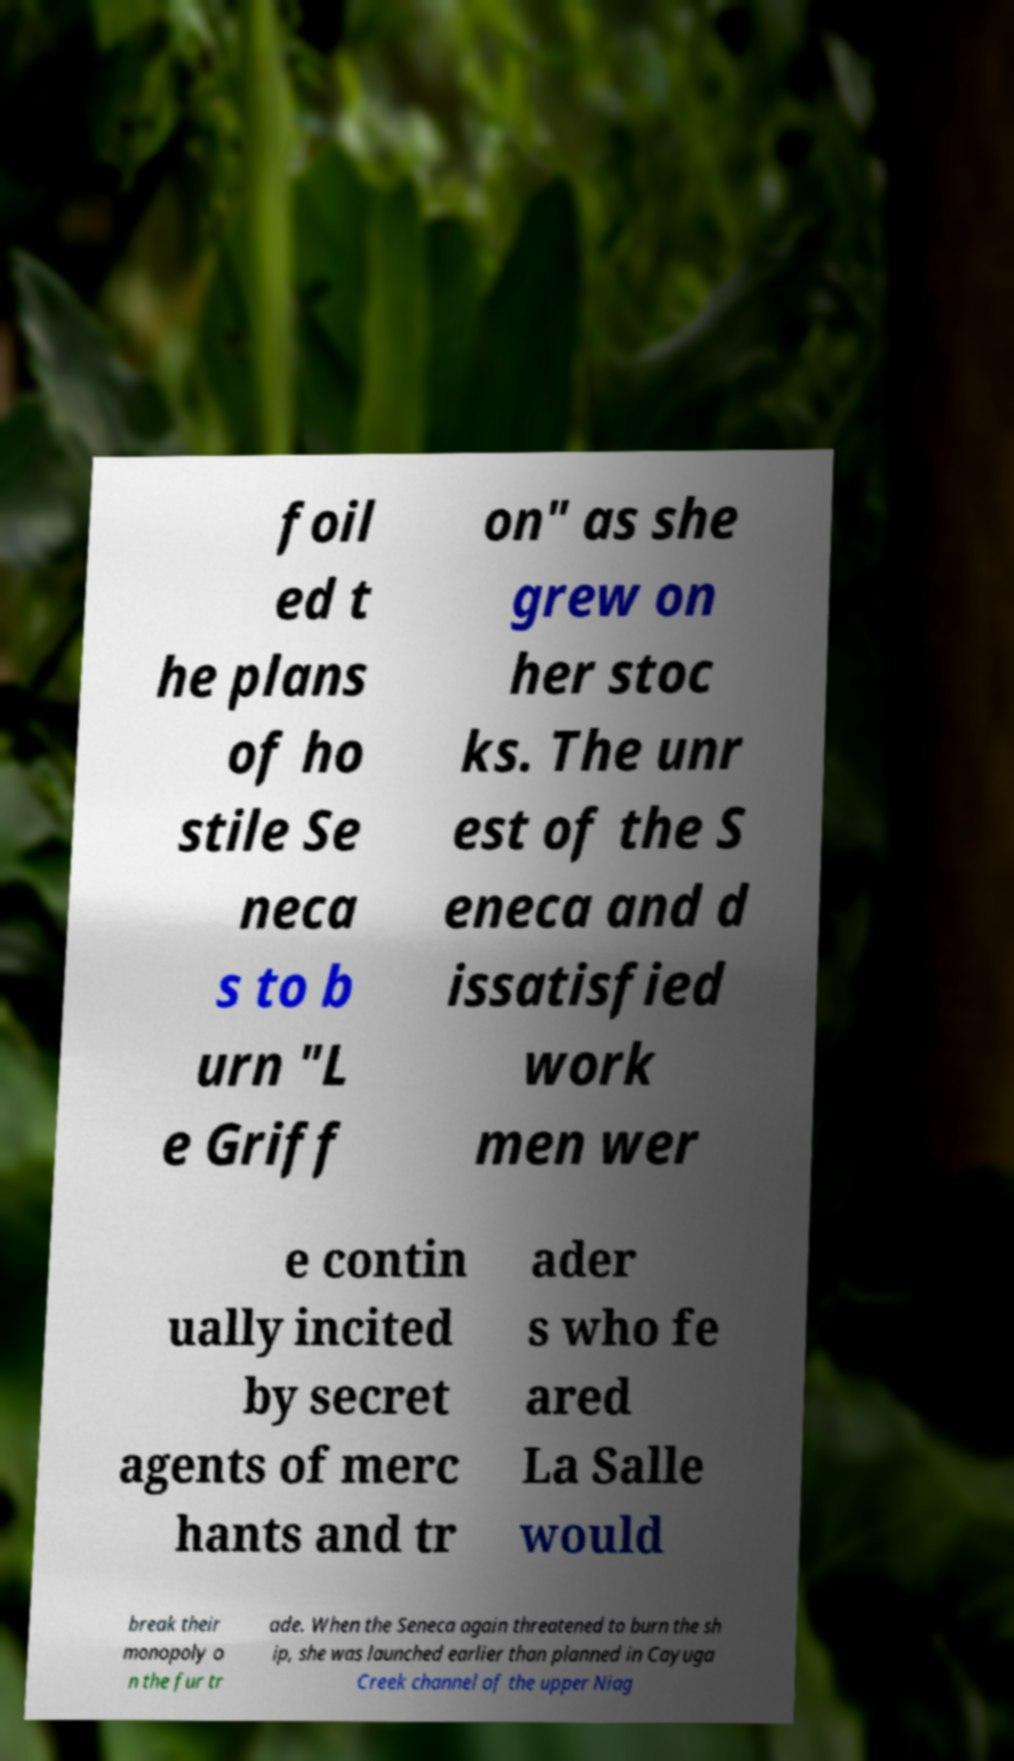Please identify and transcribe the text found in this image. foil ed t he plans of ho stile Se neca s to b urn "L e Griff on" as she grew on her stoc ks. The unr est of the S eneca and d issatisfied work men wer e contin ually incited by secret agents of merc hants and tr ader s who fe ared La Salle would break their monopoly o n the fur tr ade. When the Seneca again threatened to burn the sh ip, she was launched earlier than planned in Cayuga Creek channel of the upper Niag 